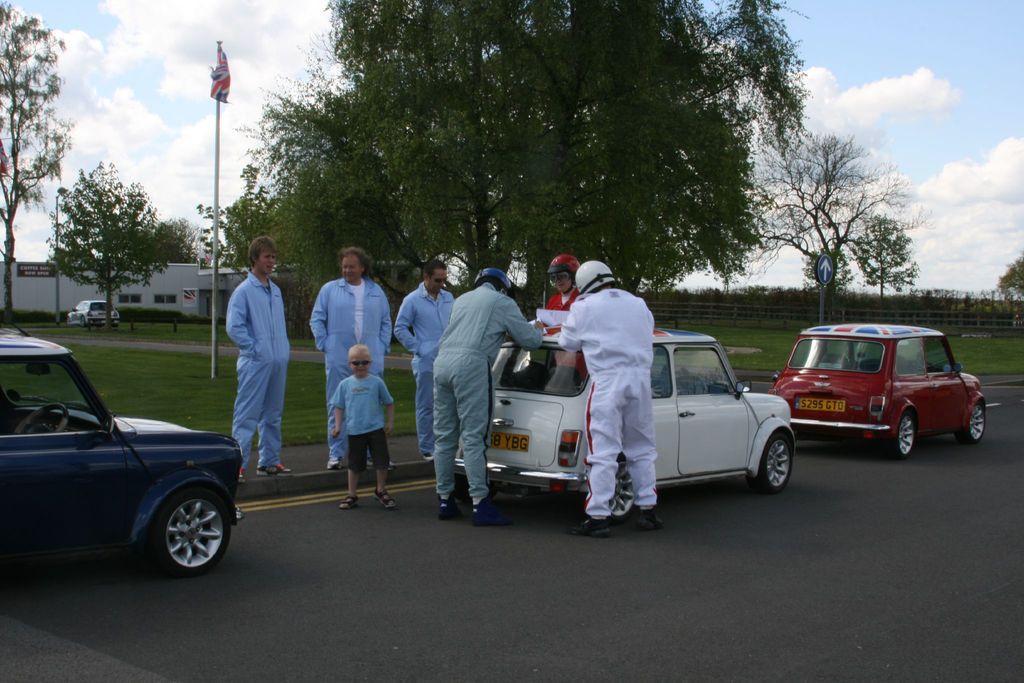Describe this image in one or two sentences. In this picture we can see vehicles, people on the road, beside this road we can see poles, flag,sign board, fence, houses, trees and we can see sky in the background. 